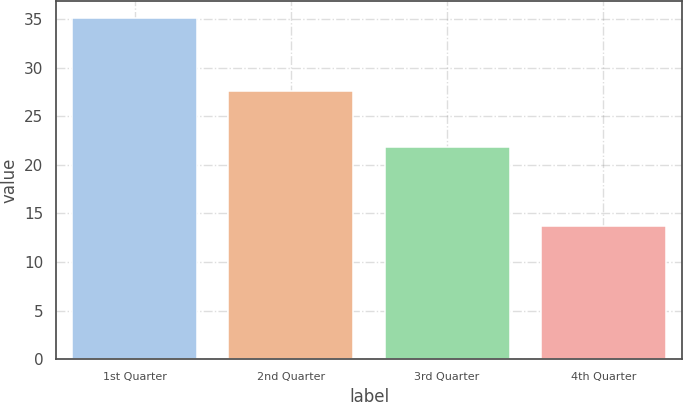Convert chart to OTSL. <chart><loc_0><loc_0><loc_500><loc_500><bar_chart><fcel>1st Quarter<fcel>2nd Quarter<fcel>3rd Quarter<fcel>4th Quarter<nl><fcel>35.1<fcel>27.61<fcel>21.85<fcel>13.68<nl></chart> 